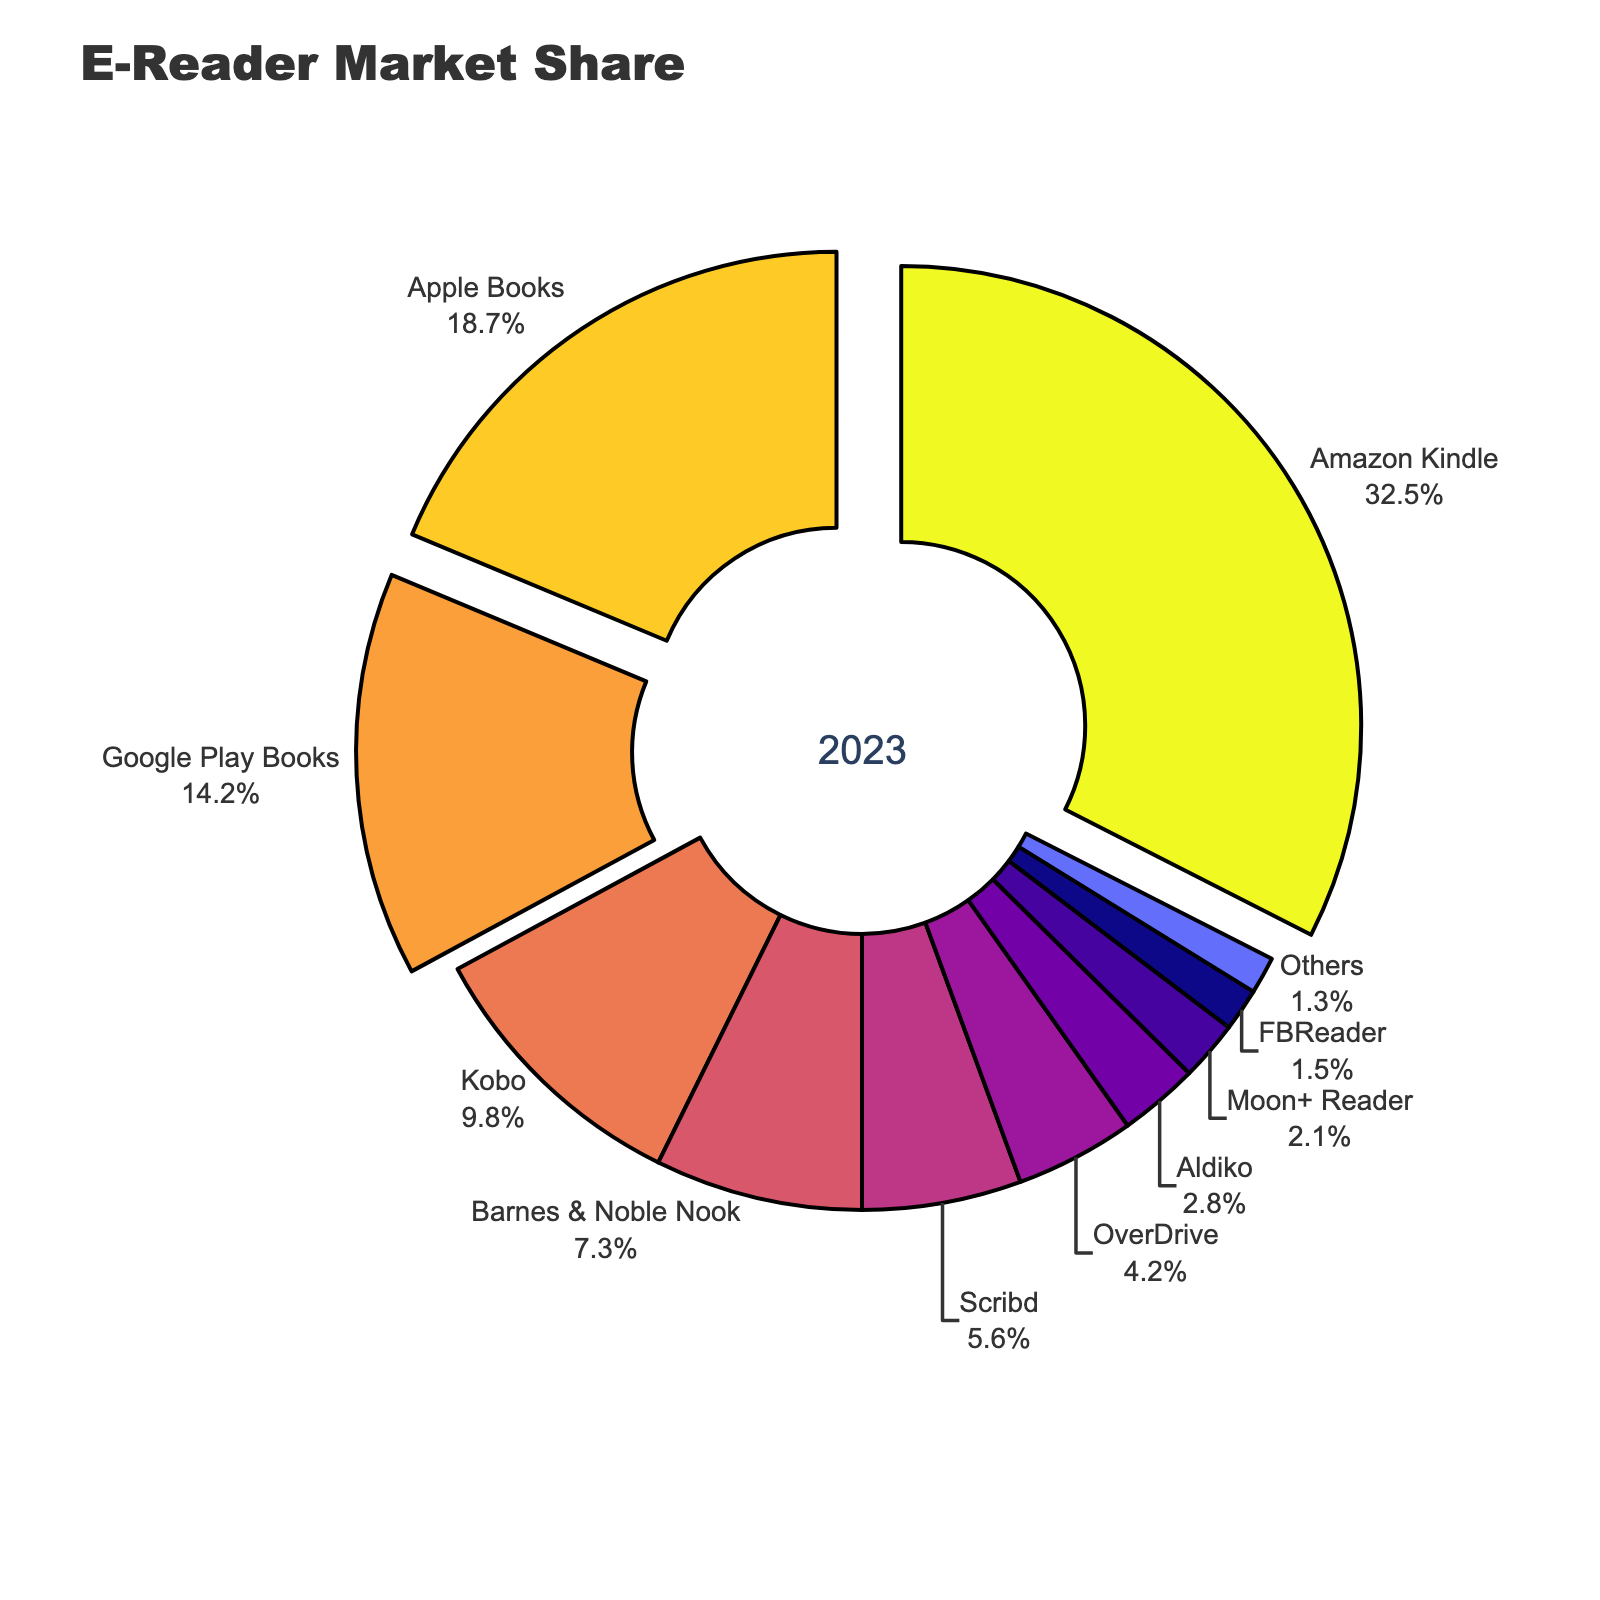Which e-reader device or app holds the largest market share? The figure clearly shows that "Amazon Kindle" has the largest segment in the pie chart, indicated by the largest slice.
Answer: Amazon Kindle What's the combined market share of Apple Books and Google Play Books? First, identify the market shares for both Apple Books (18.7%) and Google Play Books (14.2%). Then, add them together: 18.7 + 14.2 = 32.9%.
Answer: 32.9% How does the market share of the Kobo compare to that of the Barnes & Noble Nook? From the pie chart, the Kobo has a market share of 9.8%, while the Barnes & Noble Nook has 7.3%. Kobo's share is therefore 2.5% higher than Barnes & Noble Nook.
Answer: Kobo has 2.5% more Among the top three devices/apps, which one is least popular? The top three devices/apps are Amazon Kindle, Apple Books, and Google Play Books. Google Play Books has the smallest slice among these three, representing 14.2% of the market share.
Answer: Google Play Books Which devices/apps make up less than 5% of the market individually? Observing the pie chart, Scribd, OverDrive, Aldiko, Moon+ Reader, FBReader, and Others each have less than 5% market share.
Answer: Scribd, OverDrive, Aldiko, Moon+ Reader, FBReader, Others What is the total market share of readers that fall under 2% individually? The pie chart shows that Moon+ Reader (2.1%) and FBReader (1.5%) fall under that category. Adding them together: 2.1 + 1.5 = 3.6%
Answer: 3.6% How much larger is Amazon Kindle's market share compared to Scribd? Amazon Kindle has a market share of 32.5%, while Scribd has 5.6%. The difference is 32.5 - 5.6 = 26.9%.
Answer: 26.9% Which segment occupies a segment with the deep reddish color closer to the center? The deep reddish color closer to the center is for "Barnes & Noble Nook," indicated by the visual representation.
Answer: Barnes & Noble Nook What is the average market share of the top five e-reader devices/apps? The top five devices/apps are Amazon Kindle (32.5%), Apple Books (18.7%), Google Play Books (14.2%), Kobo (9.8%), and Barnes & Noble Nook (7.3%). Adding them: 32.5 + 18.7 + 14.2 + 9.8 + 7.3 = 82.5. The average is 82.5 / 5 = 16.5%.
Answer: 16.5% What's the difference in market share between the most and least popular e-reader device/app? The most popular is Amazon Kindle (32.5%), and the least popular is Others (1.3%). The difference is 32.5 - 1.3 = 31.2%.
Answer: 31.2% 